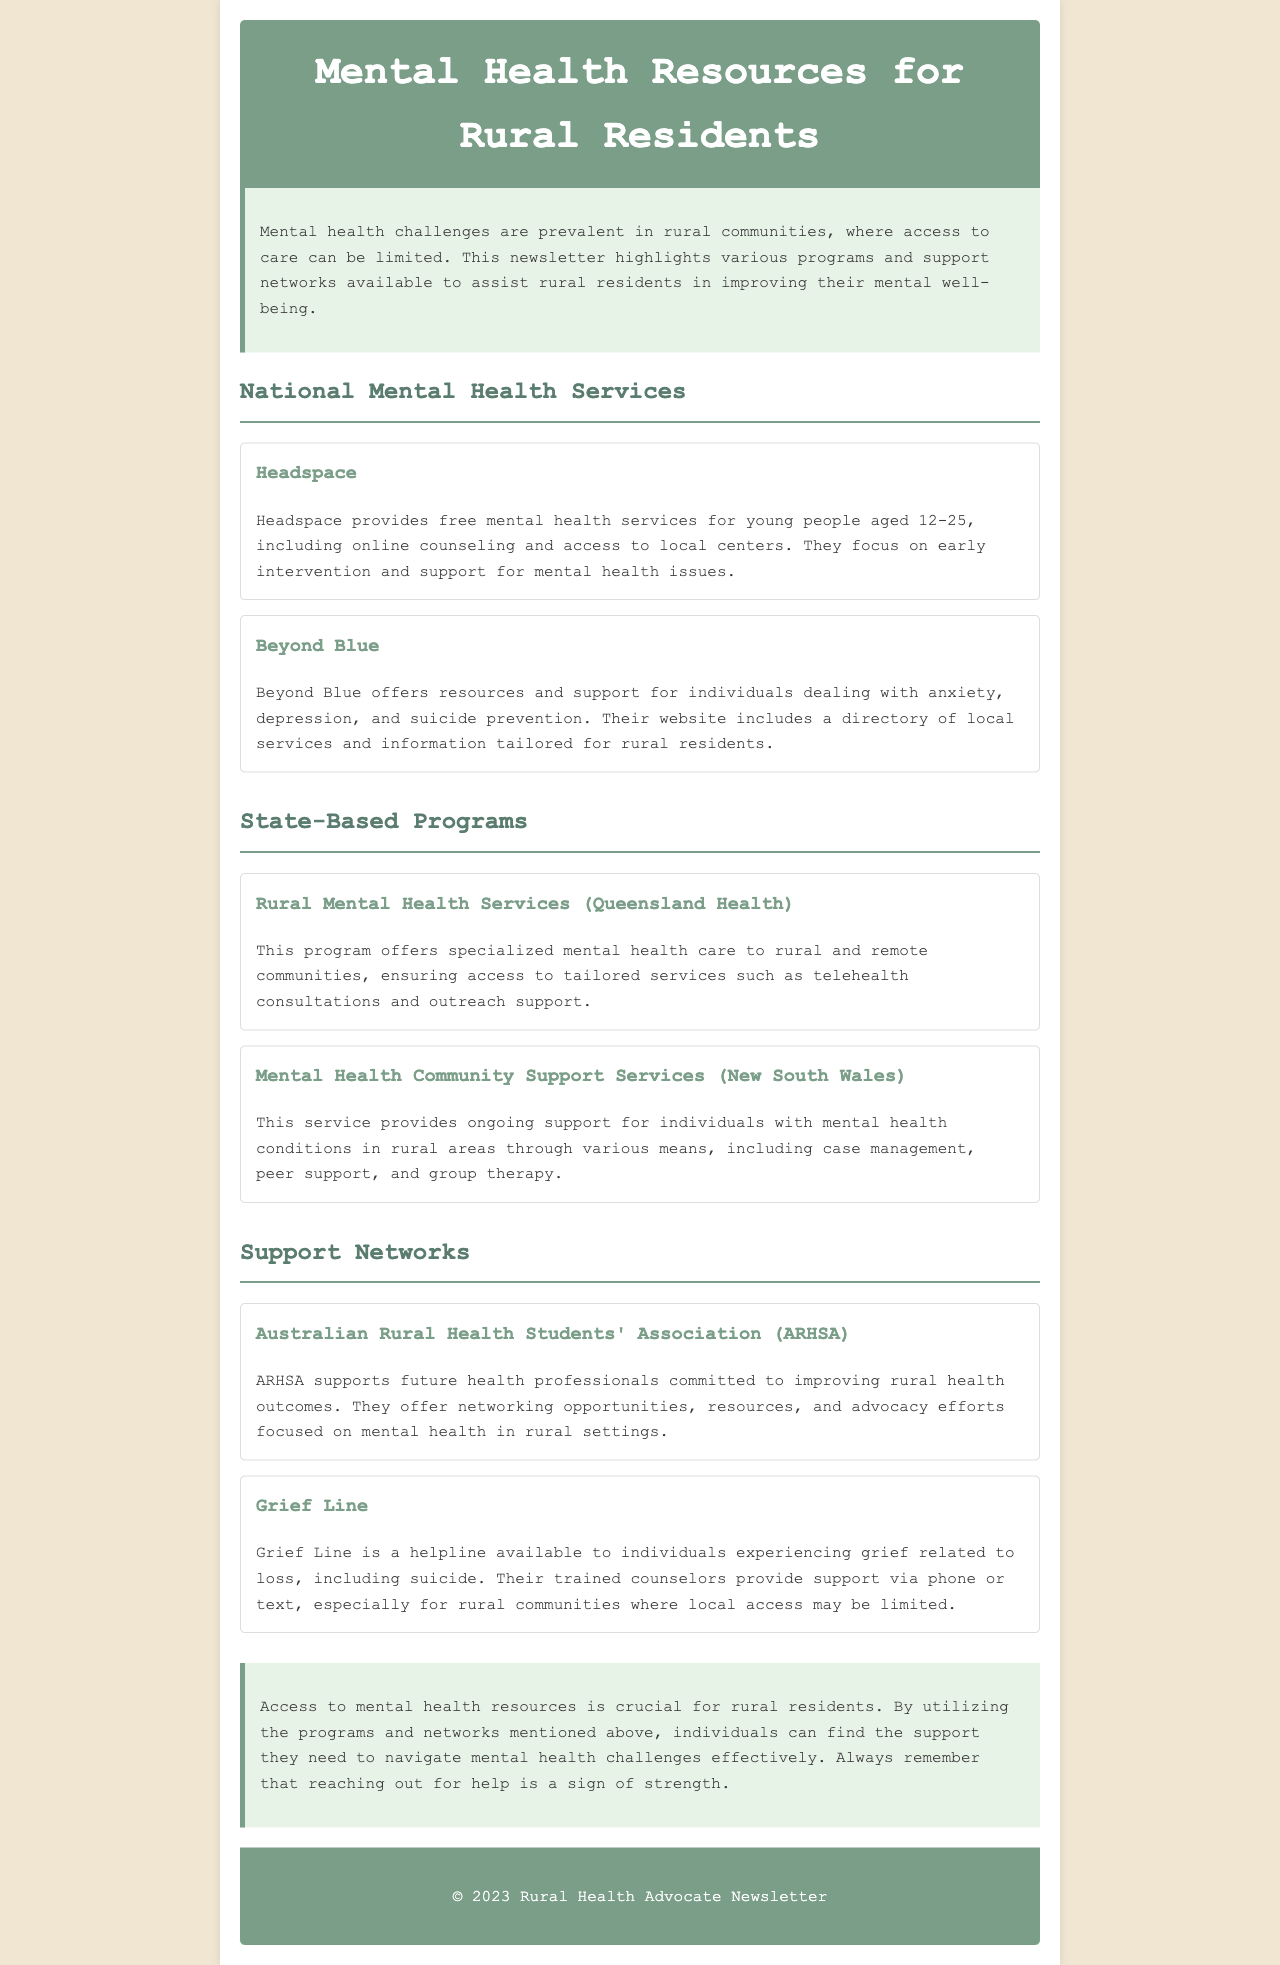What age group does Headspace serve? Headspace provides services for young people aged 12-25, as stated in the document.
Answer: 12-25 What type of support does Beyond Blue offer? Beyond Blue offers resources and support for anxiety, depression, and suicide prevention according to the newsletter.
Answer: Anxiety, depression, and suicide prevention Which two states are mentioned with specific mental health programs? The document lists Queensland and New South Wales as states with specific mental health programs.
Answer: Queensland and New South Wales What service does Grief Line provide? Grief Line offers a helpline for individuals experiencing grief related to loss, including suicide, as explained in the newsletter.
Answer: Helpline for grief Why is access to mental health resources important for rural residents? The document emphasizes that access is crucial for rural residents to effectively navigate mental health challenges.
Answer: Crucial for navigation of mental health challenges What does the Australian Rural Health Students' Association focus on? The ARHSA focuses on supporting future health professionals committed to improving rural health outcomes, as outlined in the section.
Answer: Improving rural health outcomes How does Queensland Health ensure access to services? Queensland Health ensures access through telehealth consultations and outreach support, mentioned in the state programs section.
Answer: Telehealth consultations and outreach support What is the overall aim of the newsletter? The newsletter aims to highlight various programs and support networks for rural residents regarding mental health.
Answer: Highlight programs and support networks What is a key message at the end of the document? The conclusion of the document highlights that reaching out for help is a sign of strength.
Answer: Reaching out for help is a sign of strength 